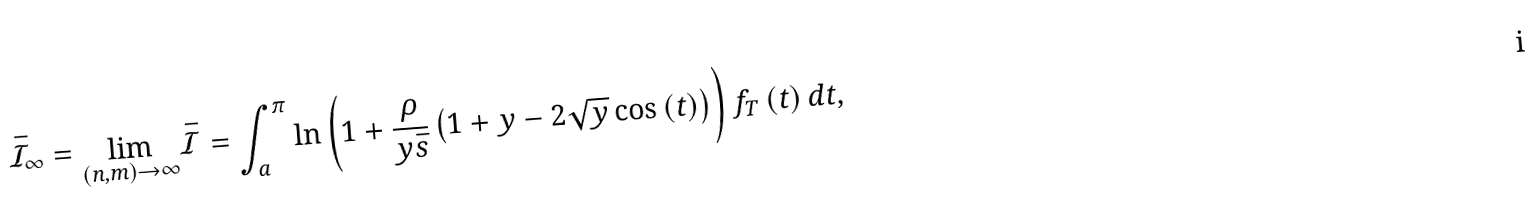Convert formula to latex. <formula><loc_0><loc_0><loc_500><loc_500>\bar { \mathcal { I } } _ { \infty } = \underset { \left ( n , m \right ) \rightarrow \infty } { \lim } \bar { \mathcal { I } } = \int _ { a } ^ { \pi } \ln \left ( 1 + \frac { \rho } { y \bar { s } } \left ( 1 + y - 2 \sqrt { y } \cos \left ( t \right ) \right ) \right ) f _ { T } \left ( t \right ) d t ,</formula> 